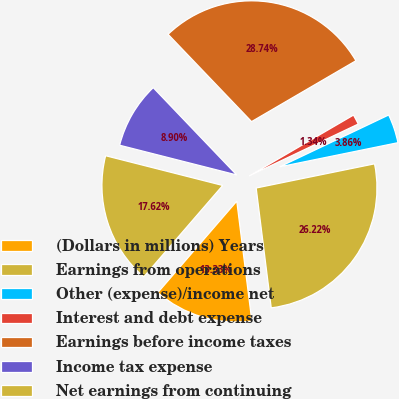Convert chart. <chart><loc_0><loc_0><loc_500><loc_500><pie_chart><fcel>(Dollars in millions) Years<fcel>Earnings from operations<fcel>Other (expense)/income net<fcel>Interest and debt expense<fcel>Earnings before income taxes<fcel>Income tax expense<fcel>Net earnings from continuing<nl><fcel>13.33%<fcel>26.22%<fcel>3.86%<fcel>1.34%<fcel>28.74%<fcel>8.9%<fcel>17.62%<nl></chart> 